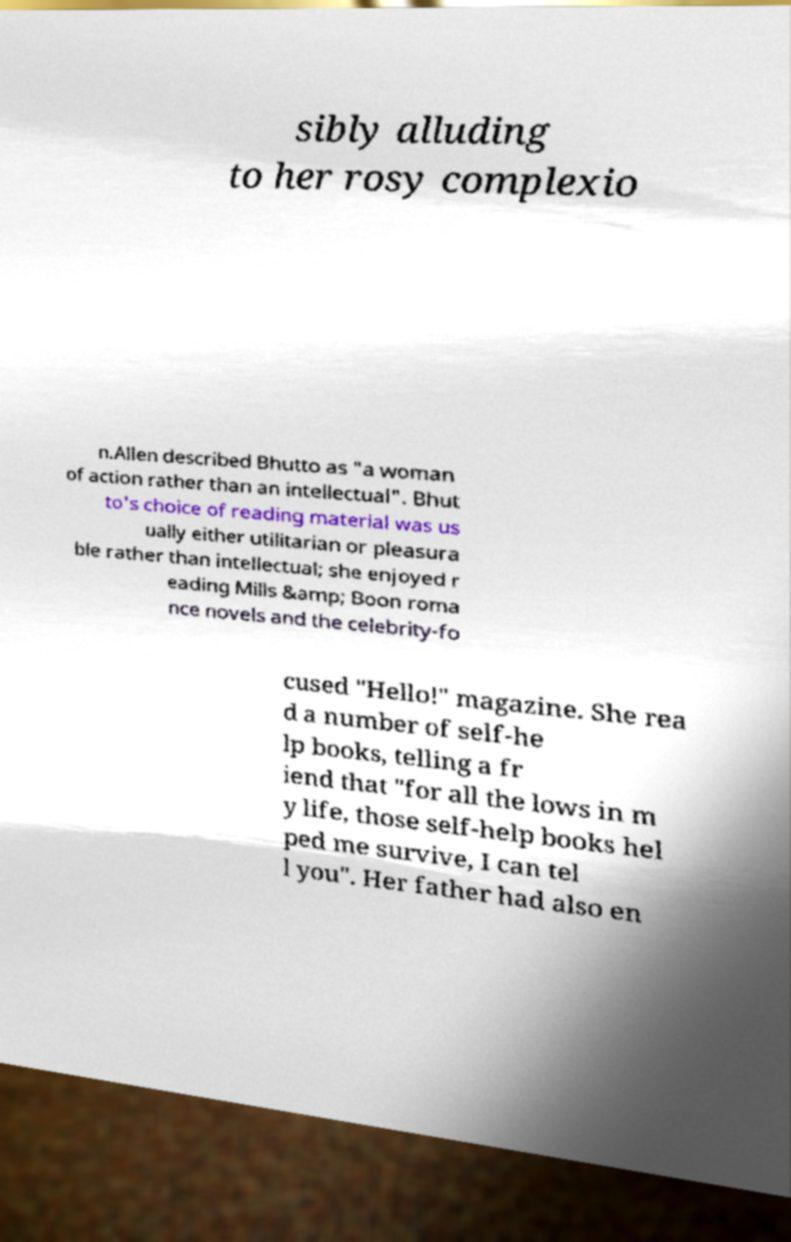Could you extract and type out the text from this image? sibly alluding to her rosy complexio n.Allen described Bhutto as "a woman of action rather than an intellectual". Bhut to's choice of reading material was us ually either utilitarian or pleasura ble rather than intellectual; she enjoyed r eading Mills &amp; Boon roma nce novels and the celebrity-fo cused "Hello!" magazine. She rea d a number of self-he lp books, telling a fr iend that "for all the lows in m y life, those self-help books hel ped me survive, I can tel l you". Her father had also en 